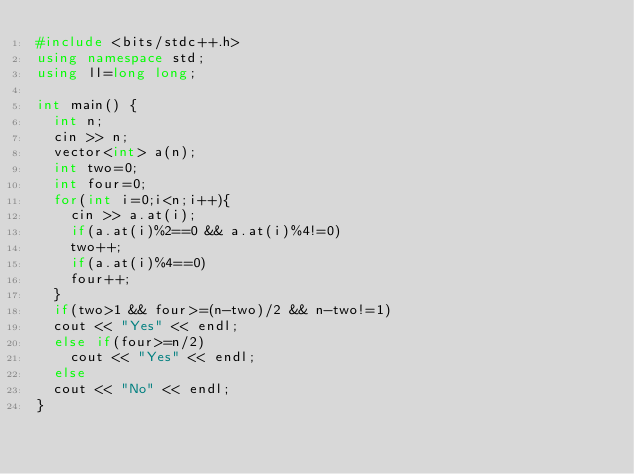Convert code to text. <code><loc_0><loc_0><loc_500><loc_500><_C++_>#include <bits/stdc++.h>
using namespace std;
using ll=long long;

int main() {
  int n;
  cin >> n;
  vector<int> a(n);
  int two=0;
  int four=0;
  for(int i=0;i<n;i++){
    cin >> a.at(i);
    if(a.at(i)%2==0 && a.at(i)%4!=0)
    two++;
    if(a.at(i)%4==0)
    four++;
  }
  if(two>1 && four>=(n-two)/2 && n-two!=1)
  cout << "Yes" << endl;
  else if(four>=n/2)
    cout << "Yes" << endl;
  else
  cout << "No" << endl;
}

</code> 